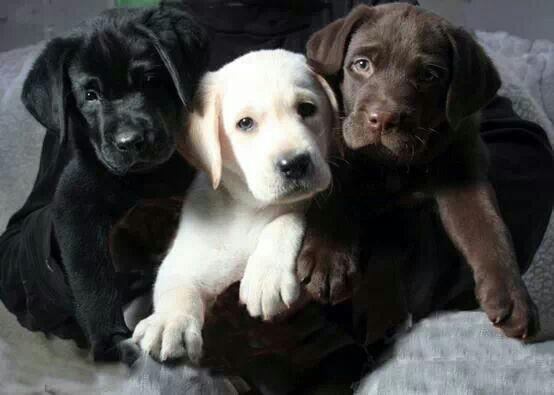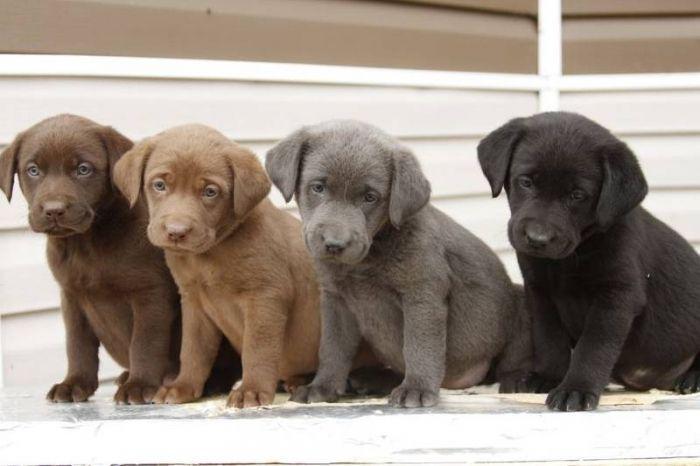The first image is the image on the left, the second image is the image on the right. For the images displayed, is the sentence "A pure white puppy is between a dark brown puppy and a black puppy." factually correct? Answer yes or no. Yes. The first image is the image on the left, the second image is the image on the right. Examine the images to the left and right. Is the description "There are three dogs sitting on the grass, one black, one brown and one golden." accurate? Answer yes or no. No. 